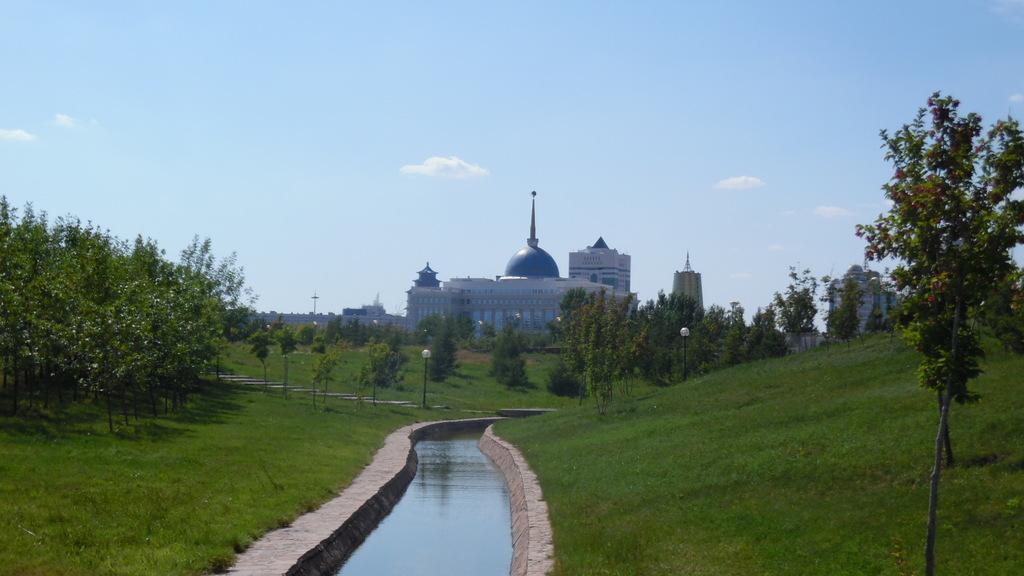Could you give a brief overview of what you see in this image? In this image we can see the trees, grass, beside that we can see water and street lights, behind we can see the buildings, at the top we can see the sky with clouds. 